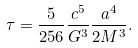Convert formula to latex. <formula><loc_0><loc_0><loc_500><loc_500>\tau = \frac { 5 } { 2 5 6 } \frac { c ^ { 5 } } { G ^ { 3 } } \frac { a ^ { 4 } } { 2 M ^ { 3 } } .</formula> 